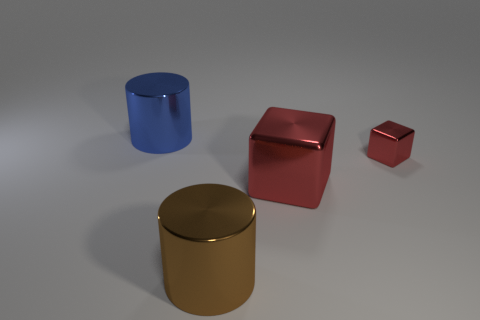How many cylinders are either big blue metal objects or red things?
Ensure brevity in your answer.  1. Do the metal cylinder that is in front of the big blue metallic object and the cylinder behind the big brown cylinder have the same size?
Make the answer very short. Yes. There is a big red thing on the right side of the cylinder that is on the left side of the large brown cylinder; what is its material?
Give a very brief answer. Metal. Is the number of blocks that are in front of the tiny shiny block less than the number of tiny metallic things?
Your response must be concise. No. There is a brown object that is the same material as the big blue cylinder; what is its shape?
Offer a terse response. Cylinder. What number of other things are the same shape as the brown thing?
Make the answer very short. 1. How many green objects are small metallic cubes or large blocks?
Provide a short and direct response. 0. Is the big blue metal thing the same shape as the big red metallic thing?
Your answer should be very brief. No. There is a red metallic thing that is on the right side of the large red thing; is there a tiny red object in front of it?
Provide a succinct answer. No. Are there an equal number of big metallic cubes on the left side of the large blue thing and large gray metal spheres?
Your answer should be compact. Yes. 